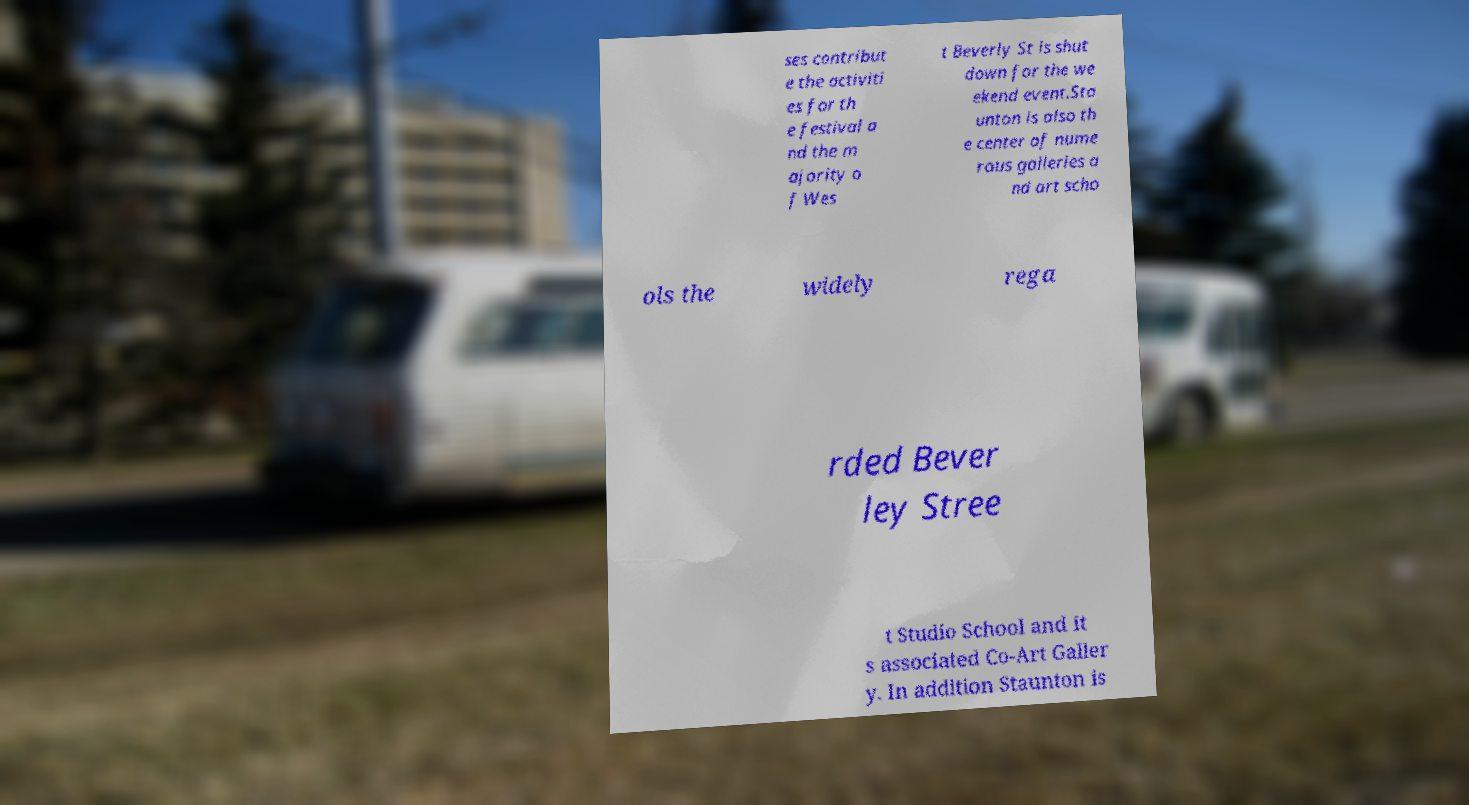For documentation purposes, I need the text within this image transcribed. Could you provide that? ses contribut e the activiti es for th e festival a nd the m ajority o f Wes t Beverly St is shut down for the we ekend event.Sta unton is also th e center of nume rous galleries a nd art scho ols the widely rega rded Bever ley Stree t Studio School and it s associated Co-Art Galler y. In addition Staunton is 